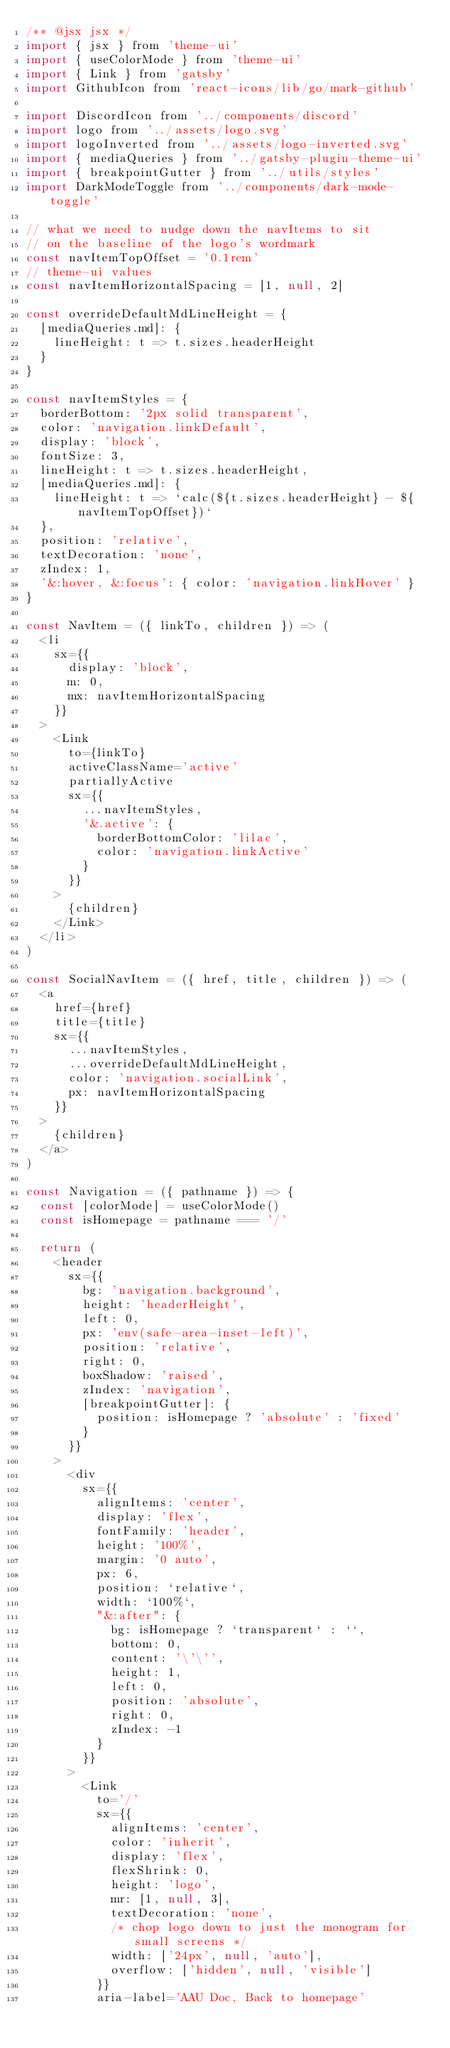<code> <loc_0><loc_0><loc_500><loc_500><_JavaScript_>/** @jsx jsx */
import { jsx } from 'theme-ui'
import { useColorMode } from 'theme-ui'
import { Link } from 'gatsby'
import GithubIcon from 'react-icons/lib/go/mark-github'

import DiscordIcon from '../components/discord'
import logo from '../assets/logo.svg'
import logoInverted from '../assets/logo-inverted.svg'
import { mediaQueries } from '../gatsby-plugin-theme-ui'
import { breakpointGutter } from '../utils/styles'
import DarkModeToggle from '../components/dark-mode-toggle'

// what we need to nudge down the navItems to sit
// on the baseline of the logo's wordmark
const navItemTopOffset = '0.1rem'
// theme-ui values
const navItemHorizontalSpacing = [1, null, 2]

const overrideDefaultMdLineHeight = {
  [mediaQueries.md]: {
    lineHeight: t => t.sizes.headerHeight
  }
}

const navItemStyles = {
  borderBottom: '2px solid transparent',
  color: 'navigation.linkDefault',
  display: 'block',
  fontSize: 3,
  lineHeight: t => t.sizes.headerHeight,
  [mediaQueries.md]: {
    lineHeight: t => `calc(${t.sizes.headerHeight} - ${navItemTopOffset})`
  },
  position: 'relative',
  textDecoration: 'none',
  zIndex: 1,
  '&:hover, &:focus': { color: 'navigation.linkHover' }
}

const NavItem = ({ linkTo, children }) => (
  <li
    sx={{
      display: 'block',
      m: 0,
      mx: navItemHorizontalSpacing
    }}
  >
    <Link
      to={linkTo}
      activeClassName='active'
      partiallyActive
      sx={{
        ...navItemStyles,
        '&.active': {
          borderBottomColor: 'lilac',
          color: 'navigation.linkActive'
        }
      }}
    >
      {children}
    </Link>
  </li>
)

const SocialNavItem = ({ href, title, children }) => (
  <a
    href={href}
    title={title}
    sx={{
      ...navItemStyles,
      ...overrideDefaultMdLineHeight,
      color: 'navigation.socialLink',
      px: navItemHorizontalSpacing
    }}
  >
    {children}
  </a>
)

const Navigation = ({ pathname }) => {
  const [colorMode] = useColorMode()
  const isHomepage = pathname === '/'

  return (
    <header
      sx={{
        bg: 'navigation.background',
        height: 'headerHeight',
        left: 0,
        px: 'env(safe-area-inset-left)',
        position: 'relative',
        right: 0,
        boxShadow: 'raised',
        zIndex: 'navigation',
        [breakpointGutter]: {
          position: isHomepage ? 'absolute' : 'fixed'
        }
      }}
    >
      <div
        sx={{
          alignItems: 'center',
          display: 'flex',
          fontFamily: 'header',
          height: '100%',
          margin: '0 auto',
          px: 6,
          position: `relative`,
          width: `100%`,
          "&:after": {
            bg: isHomepage ? `transparent` : ``,
            bottom: 0,
            content: '\'\'',
            height: 1,
            left: 0,
            position: 'absolute',
            right: 0,
            zIndex: -1
          }
        }}
      >
        <Link
          to='/'
          sx={{
            alignItems: 'center',
            color: 'inherit',
            display: 'flex',
            flexShrink: 0,
            height: 'logo',
            mr: [1, null, 3],
            textDecoration: 'none',
            /* chop logo down to just the monogram for small screens */
            width: ['24px', null, 'auto'],
            overflow: ['hidden', null, 'visible']
          }}
          aria-label='AAU Doc, Back to homepage'</code> 